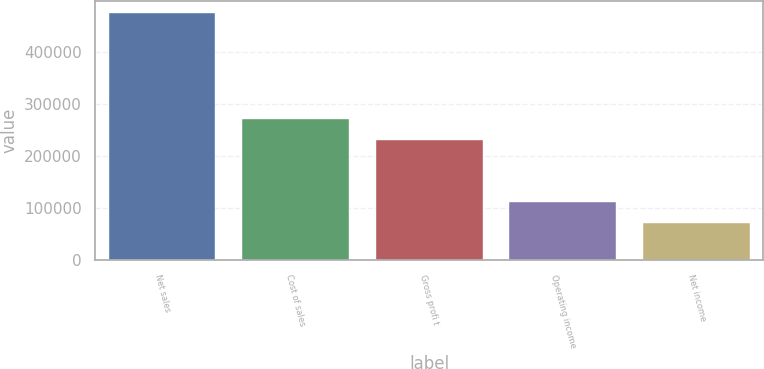Convert chart to OTSL. <chart><loc_0><loc_0><loc_500><loc_500><bar_chart><fcel>Net sales<fcel>Cost of sales<fcel>Gross profi t<fcel>Operating income<fcel>Net income<nl><fcel>475611<fcel>271149<fcel>230747<fcel>111997<fcel>71595<nl></chart> 